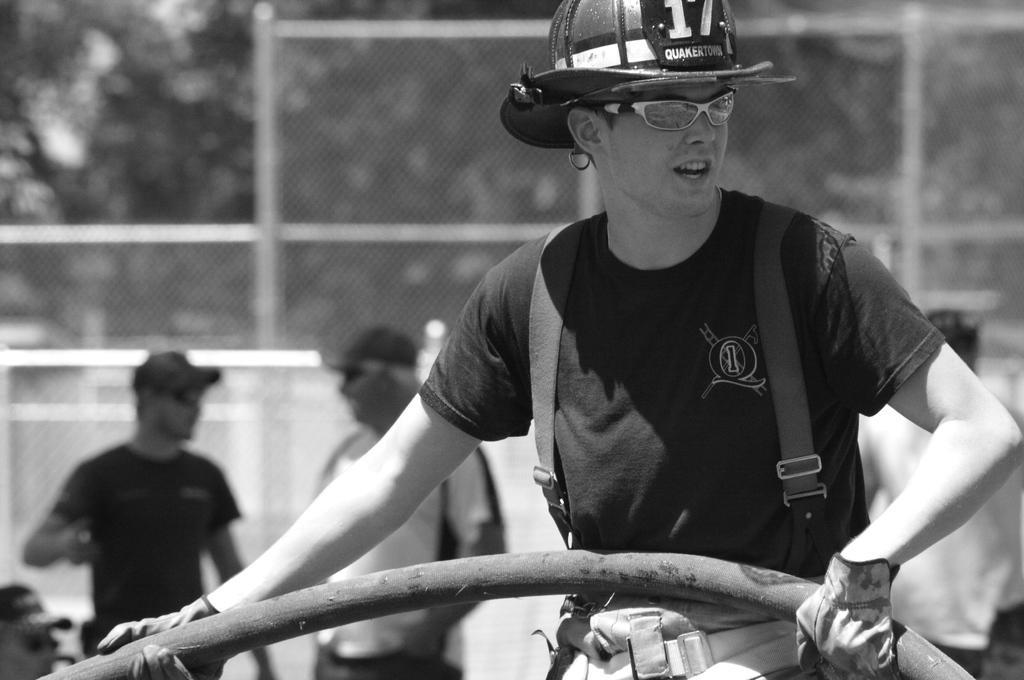In one or two sentences, can you explain what this image depicts? In this picture we can see a man is holding a pipe in the front, he is wearing a cap, goggles and gloves, there are three persons in the middle, in the background there are trees and fencing, it is a black and white image. 